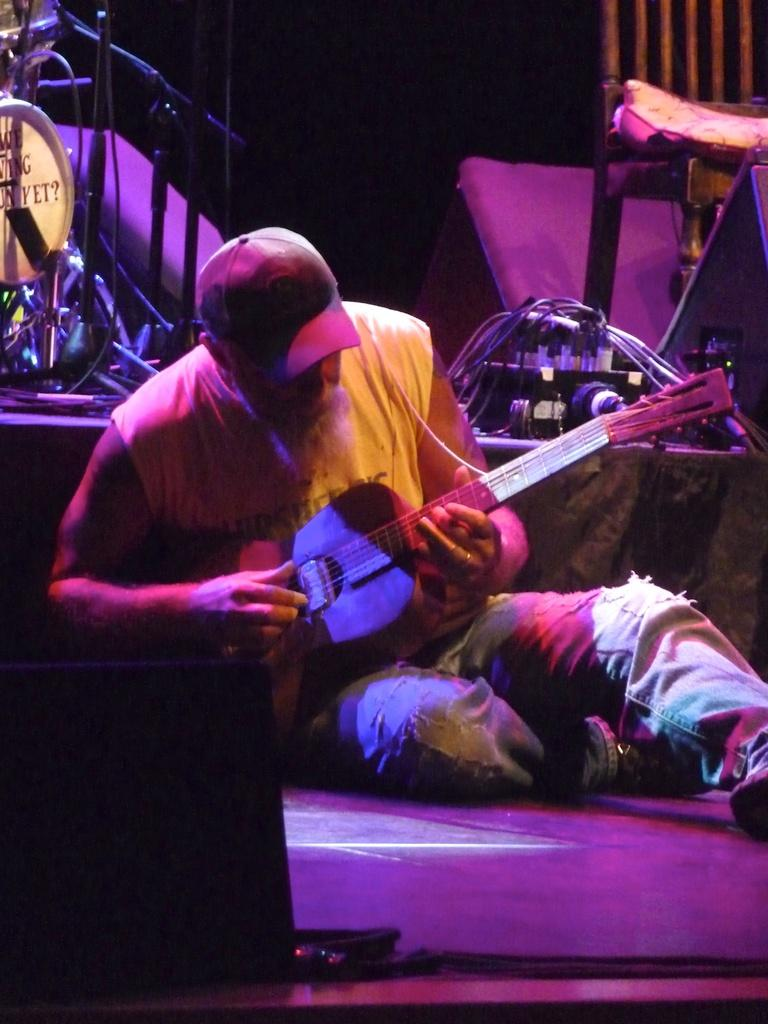What is the person in the image doing? The person is sitting down in the image. What is the person wearing on their upper body? The person is wearing a yellow sando. What type of headwear is the person wearing? The person is wearing a red cap. What musical instrument is the person playing? The person is playing a guitar. What type of equipment can be seen in the image? There are cables visible in the image. What type of furniture is present in the image? There is a chair in the image. What type of lumber is the person using to play the guitar in the image? There is no lumber present in the image, and the person is not using any lumber to play the guitar. Is the person's father visible in the image? There is no information about the person's father in the image, and no other person is visible. 